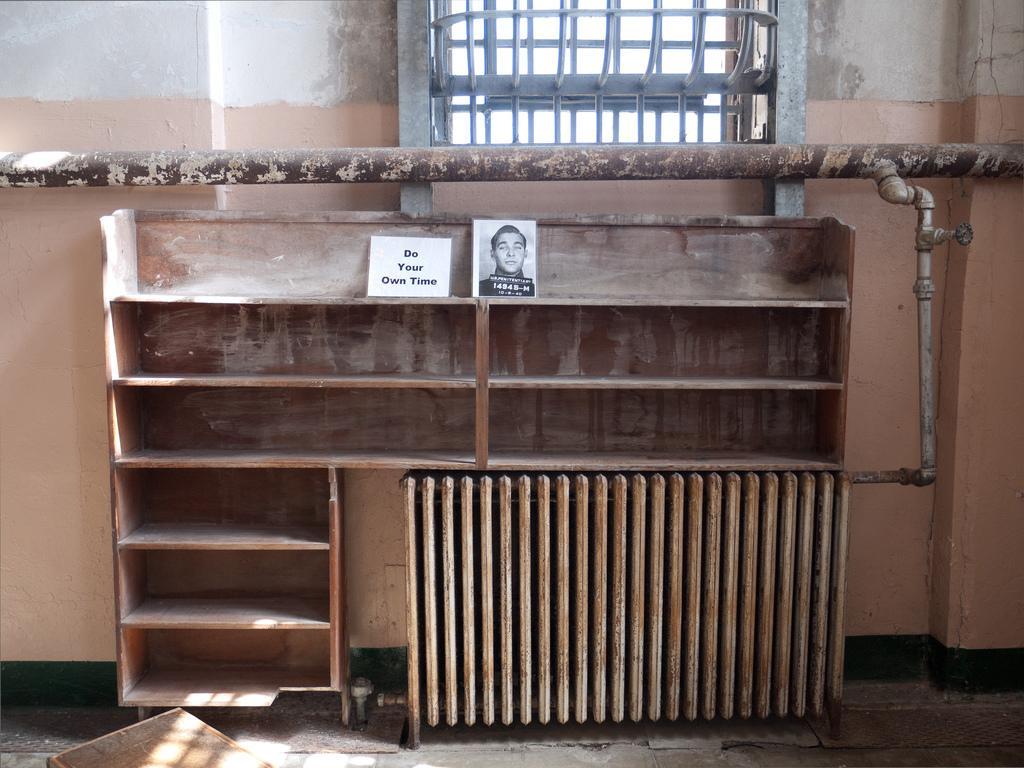In one or two sentences, can you explain what this image depicts? In the picture I can see the wooden shelves. I can see a photo and a piece of paper with text on the wooden shelf. I can see a wooden block on the bottom left side of the picture. I can see a metal grill glass window at the top of the picture. I can see a metal pipeline on the wall. 